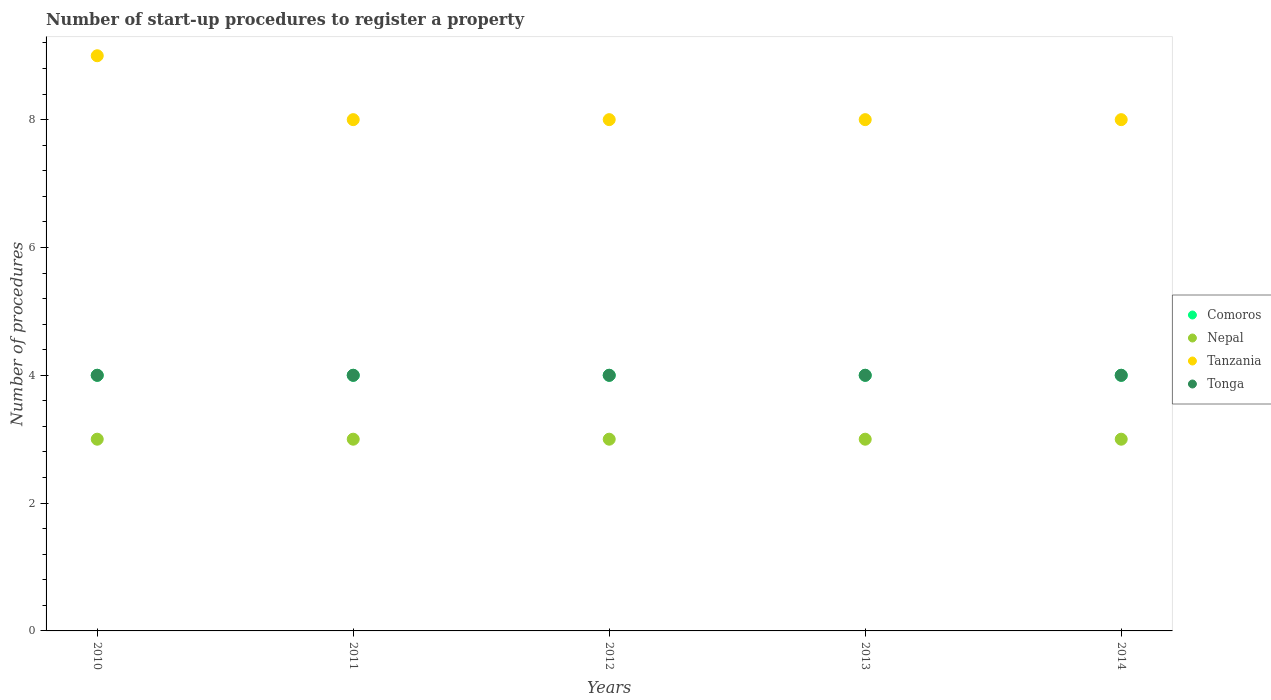How many different coloured dotlines are there?
Ensure brevity in your answer.  4. Is the number of dotlines equal to the number of legend labels?
Ensure brevity in your answer.  Yes. What is the number of procedures required to register a property in Tonga in 2012?
Keep it short and to the point. 4. Across all years, what is the maximum number of procedures required to register a property in Tonga?
Offer a very short reply. 4. Across all years, what is the minimum number of procedures required to register a property in Nepal?
Your response must be concise. 3. In which year was the number of procedures required to register a property in Tanzania minimum?
Provide a succinct answer. 2011. What is the total number of procedures required to register a property in Tanzania in the graph?
Provide a succinct answer. 41. What is the difference between the number of procedures required to register a property in Tonga in 2011 and that in 2014?
Give a very brief answer. 0. What is the difference between the number of procedures required to register a property in Nepal in 2010 and the number of procedures required to register a property in Tonga in 2012?
Ensure brevity in your answer.  -1. In the year 2012, what is the difference between the number of procedures required to register a property in Nepal and number of procedures required to register a property in Tonga?
Make the answer very short. -1. Is the number of procedures required to register a property in Comoros in 2012 less than that in 2014?
Keep it short and to the point. No. Is the difference between the number of procedures required to register a property in Nepal in 2011 and 2012 greater than the difference between the number of procedures required to register a property in Tonga in 2011 and 2012?
Your response must be concise. No. What is the difference between the highest and the lowest number of procedures required to register a property in Tanzania?
Your answer should be compact. 1. In how many years, is the number of procedures required to register a property in Tonga greater than the average number of procedures required to register a property in Tonga taken over all years?
Provide a short and direct response. 0. Is it the case that in every year, the sum of the number of procedures required to register a property in Comoros and number of procedures required to register a property in Tonga  is greater than the number of procedures required to register a property in Nepal?
Provide a succinct answer. Yes. Does the number of procedures required to register a property in Nepal monotonically increase over the years?
Ensure brevity in your answer.  No. How many dotlines are there?
Keep it short and to the point. 4. How many years are there in the graph?
Your answer should be very brief. 5. What is the difference between two consecutive major ticks on the Y-axis?
Your answer should be compact. 2. Are the values on the major ticks of Y-axis written in scientific E-notation?
Offer a terse response. No. Does the graph contain any zero values?
Offer a terse response. No. Where does the legend appear in the graph?
Provide a short and direct response. Center right. How many legend labels are there?
Ensure brevity in your answer.  4. How are the legend labels stacked?
Ensure brevity in your answer.  Vertical. What is the title of the graph?
Make the answer very short. Number of start-up procedures to register a property. What is the label or title of the X-axis?
Provide a short and direct response. Years. What is the label or title of the Y-axis?
Provide a short and direct response. Number of procedures. What is the Number of procedures of Comoros in 2010?
Offer a terse response. 4. What is the Number of procedures of Nepal in 2010?
Provide a short and direct response. 3. What is the Number of procedures of Tanzania in 2010?
Your answer should be compact. 9. What is the Number of procedures in Tonga in 2010?
Provide a succinct answer. 4. What is the Number of procedures of Nepal in 2011?
Your response must be concise. 3. What is the Number of procedures in Tonga in 2011?
Keep it short and to the point. 4. What is the Number of procedures in Nepal in 2012?
Provide a succinct answer. 3. What is the Number of procedures in Tanzania in 2012?
Make the answer very short. 8. What is the Number of procedures in Nepal in 2014?
Offer a very short reply. 3. What is the Number of procedures in Tanzania in 2014?
Your answer should be compact. 8. Across all years, what is the maximum Number of procedures in Comoros?
Make the answer very short. 4. Across all years, what is the maximum Number of procedures in Tanzania?
Provide a short and direct response. 9. Across all years, what is the maximum Number of procedures in Tonga?
Your response must be concise. 4. Across all years, what is the minimum Number of procedures of Tanzania?
Give a very brief answer. 8. Across all years, what is the minimum Number of procedures in Tonga?
Ensure brevity in your answer.  4. What is the total Number of procedures of Tanzania in the graph?
Offer a terse response. 41. What is the total Number of procedures in Tonga in the graph?
Keep it short and to the point. 20. What is the difference between the Number of procedures in Comoros in 2010 and that in 2011?
Your response must be concise. 0. What is the difference between the Number of procedures of Nepal in 2010 and that in 2011?
Offer a terse response. 0. What is the difference between the Number of procedures of Tanzania in 2010 and that in 2011?
Provide a short and direct response. 1. What is the difference between the Number of procedures in Comoros in 2010 and that in 2012?
Your answer should be very brief. 0. What is the difference between the Number of procedures of Nepal in 2010 and that in 2012?
Give a very brief answer. 0. What is the difference between the Number of procedures in Tonga in 2010 and that in 2012?
Your answer should be compact. 0. What is the difference between the Number of procedures of Nepal in 2010 and that in 2013?
Offer a very short reply. 0. What is the difference between the Number of procedures of Tanzania in 2010 and that in 2013?
Your answer should be very brief. 1. What is the difference between the Number of procedures in Tonga in 2010 and that in 2013?
Your response must be concise. 0. What is the difference between the Number of procedures in Comoros in 2010 and that in 2014?
Provide a short and direct response. 0. What is the difference between the Number of procedures in Nepal in 2010 and that in 2014?
Offer a very short reply. 0. What is the difference between the Number of procedures in Tanzania in 2010 and that in 2014?
Your response must be concise. 1. What is the difference between the Number of procedures of Nepal in 2011 and that in 2012?
Your response must be concise. 0. What is the difference between the Number of procedures in Tanzania in 2011 and that in 2012?
Offer a terse response. 0. What is the difference between the Number of procedures of Comoros in 2011 and that in 2013?
Keep it short and to the point. 0. What is the difference between the Number of procedures in Nepal in 2011 and that in 2013?
Your answer should be very brief. 0. What is the difference between the Number of procedures in Tanzania in 2011 and that in 2013?
Make the answer very short. 0. What is the difference between the Number of procedures of Comoros in 2011 and that in 2014?
Your answer should be compact. 0. What is the difference between the Number of procedures of Tonga in 2011 and that in 2014?
Make the answer very short. 0. What is the difference between the Number of procedures in Nepal in 2012 and that in 2013?
Make the answer very short. 0. What is the difference between the Number of procedures in Tonga in 2012 and that in 2013?
Your answer should be compact. 0. What is the difference between the Number of procedures of Nepal in 2012 and that in 2014?
Give a very brief answer. 0. What is the difference between the Number of procedures of Tanzania in 2012 and that in 2014?
Offer a terse response. 0. What is the difference between the Number of procedures of Comoros in 2013 and that in 2014?
Offer a terse response. 0. What is the difference between the Number of procedures in Tanzania in 2013 and that in 2014?
Offer a terse response. 0. What is the difference between the Number of procedures in Comoros in 2010 and the Number of procedures in Nepal in 2011?
Your answer should be compact. 1. What is the difference between the Number of procedures of Comoros in 2010 and the Number of procedures of Tanzania in 2011?
Ensure brevity in your answer.  -4. What is the difference between the Number of procedures of Comoros in 2010 and the Number of procedures of Tonga in 2011?
Provide a succinct answer. 0. What is the difference between the Number of procedures of Tanzania in 2010 and the Number of procedures of Tonga in 2011?
Provide a succinct answer. 5. What is the difference between the Number of procedures of Comoros in 2010 and the Number of procedures of Tonga in 2012?
Your answer should be very brief. 0. What is the difference between the Number of procedures in Comoros in 2010 and the Number of procedures in Tanzania in 2013?
Your response must be concise. -4. What is the difference between the Number of procedures in Nepal in 2010 and the Number of procedures in Tonga in 2013?
Keep it short and to the point. -1. What is the difference between the Number of procedures of Comoros in 2010 and the Number of procedures of Tonga in 2014?
Make the answer very short. 0. What is the difference between the Number of procedures of Nepal in 2011 and the Number of procedures of Tanzania in 2012?
Give a very brief answer. -5. What is the difference between the Number of procedures in Comoros in 2011 and the Number of procedures in Nepal in 2013?
Offer a terse response. 1. What is the difference between the Number of procedures in Nepal in 2011 and the Number of procedures in Tanzania in 2013?
Keep it short and to the point. -5. What is the difference between the Number of procedures in Comoros in 2011 and the Number of procedures in Tanzania in 2014?
Your response must be concise. -4. What is the difference between the Number of procedures of Nepal in 2011 and the Number of procedures of Tanzania in 2014?
Ensure brevity in your answer.  -5. What is the difference between the Number of procedures in Nepal in 2012 and the Number of procedures in Tanzania in 2013?
Offer a very short reply. -5. What is the difference between the Number of procedures in Nepal in 2012 and the Number of procedures in Tonga in 2013?
Provide a short and direct response. -1. What is the difference between the Number of procedures of Comoros in 2012 and the Number of procedures of Tonga in 2014?
Your response must be concise. 0. What is the difference between the Number of procedures of Nepal in 2012 and the Number of procedures of Tonga in 2014?
Your answer should be very brief. -1. What is the difference between the Number of procedures of Comoros in 2013 and the Number of procedures of Tanzania in 2014?
Offer a terse response. -4. What is the difference between the Number of procedures in Nepal in 2013 and the Number of procedures in Tonga in 2014?
Your answer should be very brief. -1. What is the average Number of procedures in Nepal per year?
Ensure brevity in your answer.  3. What is the average Number of procedures in Tanzania per year?
Your answer should be very brief. 8.2. In the year 2010, what is the difference between the Number of procedures of Nepal and Number of procedures of Tanzania?
Provide a succinct answer. -6. In the year 2010, what is the difference between the Number of procedures of Nepal and Number of procedures of Tonga?
Your answer should be compact. -1. In the year 2010, what is the difference between the Number of procedures in Tanzania and Number of procedures in Tonga?
Provide a short and direct response. 5. In the year 2011, what is the difference between the Number of procedures in Comoros and Number of procedures in Nepal?
Your response must be concise. 1. In the year 2011, what is the difference between the Number of procedures of Comoros and Number of procedures of Tonga?
Keep it short and to the point. 0. In the year 2011, what is the difference between the Number of procedures in Nepal and Number of procedures in Tanzania?
Make the answer very short. -5. In the year 2012, what is the difference between the Number of procedures in Comoros and Number of procedures in Nepal?
Offer a terse response. 1. In the year 2012, what is the difference between the Number of procedures of Nepal and Number of procedures of Tanzania?
Ensure brevity in your answer.  -5. In the year 2012, what is the difference between the Number of procedures of Nepal and Number of procedures of Tonga?
Your answer should be very brief. -1. In the year 2013, what is the difference between the Number of procedures in Comoros and Number of procedures in Tanzania?
Your answer should be compact. -4. In the year 2013, what is the difference between the Number of procedures in Nepal and Number of procedures in Tonga?
Ensure brevity in your answer.  -1. In the year 2014, what is the difference between the Number of procedures in Tanzania and Number of procedures in Tonga?
Your answer should be very brief. 4. What is the ratio of the Number of procedures of Comoros in 2010 to that in 2011?
Your answer should be very brief. 1. What is the ratio of the Number of procedures of Tanzania in 2010 to that in 2011?
Ensure brevity in your answer.  1.12. What is the ratio of the Number of procedures of Tonga in 2010 to that in 2011?
Ensure brevity in your answer.  1. What is the ratio of the Number of procedures in Tanzania in 2010 to that in 2012?
Give a very brief answer. 1.12. What is the ratio of the Number of procedures in Tonga in 2010 to that in 2012?
Your answer should be very brief. 1. What is the ratio of the Number of procedures in Nepal in 2010 to that in 2013?
Offer a very short reply. 1. What is the ratio of the Number of procedures of Tonga in 2010 to that in 2013?
Your answer should be compact. 1. What is the ratio of the Number of procedures of Nepal in 2011 to that in 2013?
Your answer should be very brief. 1. What is the ratio of the Number of procedures in Comoros in 2011 to that in 2014?
Give a very brief answer. 1. What is the ratio of the Number of procedures of Comoros in 2012 to that in 2013?
Provide a succinct answer. 1. What is the ratio of the Number of procedures in Tanzania in 2012 to that in 2013?
Make the answer very short. 1. What is the ratio of the Number of procedures of Comoros in 2012 to that in 2014?
Offer a terse response. 1. What is the ratio of the Number of procedures of Tanzania in 2012 to that in 2014?
Your answer should be very brief. 1. What is the ratio of the Number of procedures of Tonga in 2012 to that in 2014?
Make the answer very short. 1. What is the ratio of the Number of procedures of Comoros in 2013 to that in 2014?
Your response must be concise. 1. What is the ratio of the Number of procedures of Nepal in 2013 to that in 2014?
Offer a terse response. 1. What is the difference between the highest and the second highest Number of procedures in Comoros?
Ensure brevity in your answer.  0. What is the difference between the highest and the second highest Number of procedures in Tanzania?
Give a very brief answer. 1. What is the difference between the highest and the lowest Number of procedures in Tonga?
Offer a terse response. 0. 